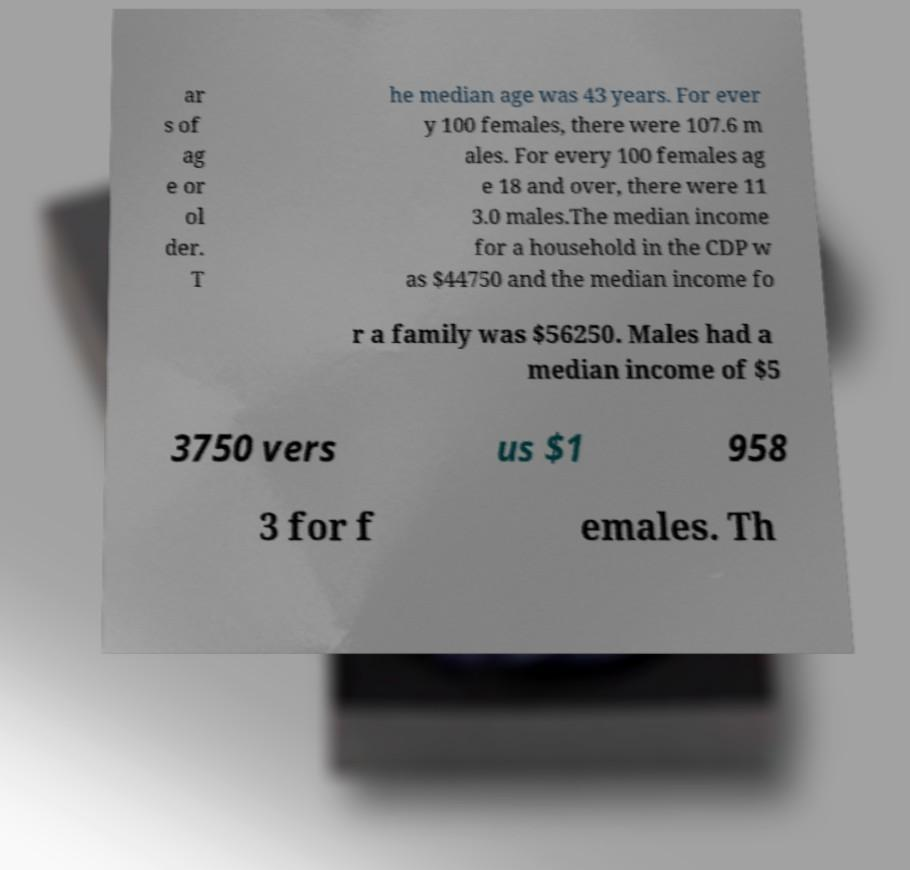What messages or text are displayed in this image? I need them in a readable, typed format. ar s of ag e or ol der. T he median age was 43 years. For ever y 100 females, there were 107.6 m ales. For every 100 females ag e 18 and over, there were 11 3.0 males.The median income for a household in the CDP w as $44750 and the median income fo r a family was $56250. Males had a median income of $5 3750 vers us $1 958 3 for f emales. Th 